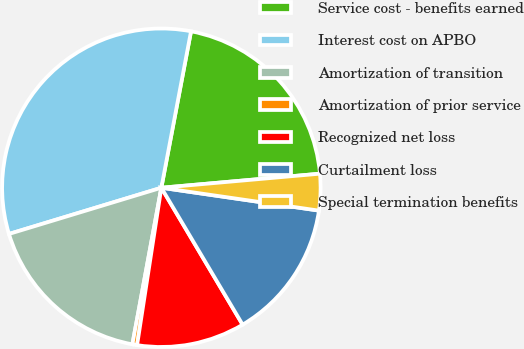Convert chart to OTSL. <chart><loc_0><loc_0><loc_500><loc_500><pie_chart><fcel>Service cost - benefits earned<fcel>Interest cost on APBO<fcel>Amortization of transition<fcel>Amortization of prior service<fcel>Recognized net loss<fcel>Curtailment loss<fcel>Special termination benefits<nl><fcel>20.61%<fcel>32.67%<fcel>17.4%<fcel>0.48%<fcel>10.96%<fcel>14.18%<fcel>3.7%<nl></chart> 